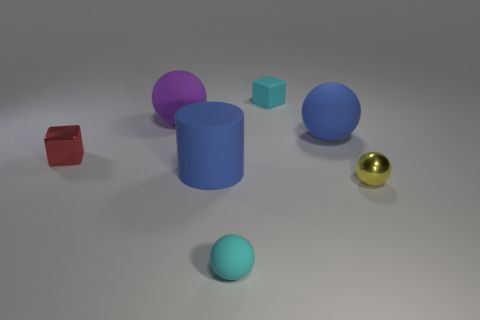How many other small things have the same material as the purple thing?
Offer a terse response. 2. There is a sphere right of the big object to the right of the cylinder; what size is it?
Your response must be concise. Small. The sphere that is on the right side of the big purple thing and behind the yellow metal sphere is what color?
Provide a short and direct response. Blue. Is the small red thing the same shape as the tiny yellow thing?
Keep it short and to the point. No. There is a rubber object that is the same color as the large cylinder; what size is it?
Make the answer very short. Large. There is a large blue object right of the blue object in front of the red metal object; what is its shape?
Keep it short and to the point. Sphere. Does the tiny yellow thing have the same shape as the tiny cyan object in front of the small red metal object?
Provide a succinct answer. Yes. What color is the matte ball that is the same size as the purple thing?
Your answer should be very brief. Blue. Are there fewer small cyan matte cubes that are behind the big cylinder than small yellow things to the left of the red shiny object?
Make the answer very short. No. The tiny cyan object behind the blue object that is left of the big blue rubber thing that is behind the tiny red thing is what shape?
Keep it short and to the point. Cube. 